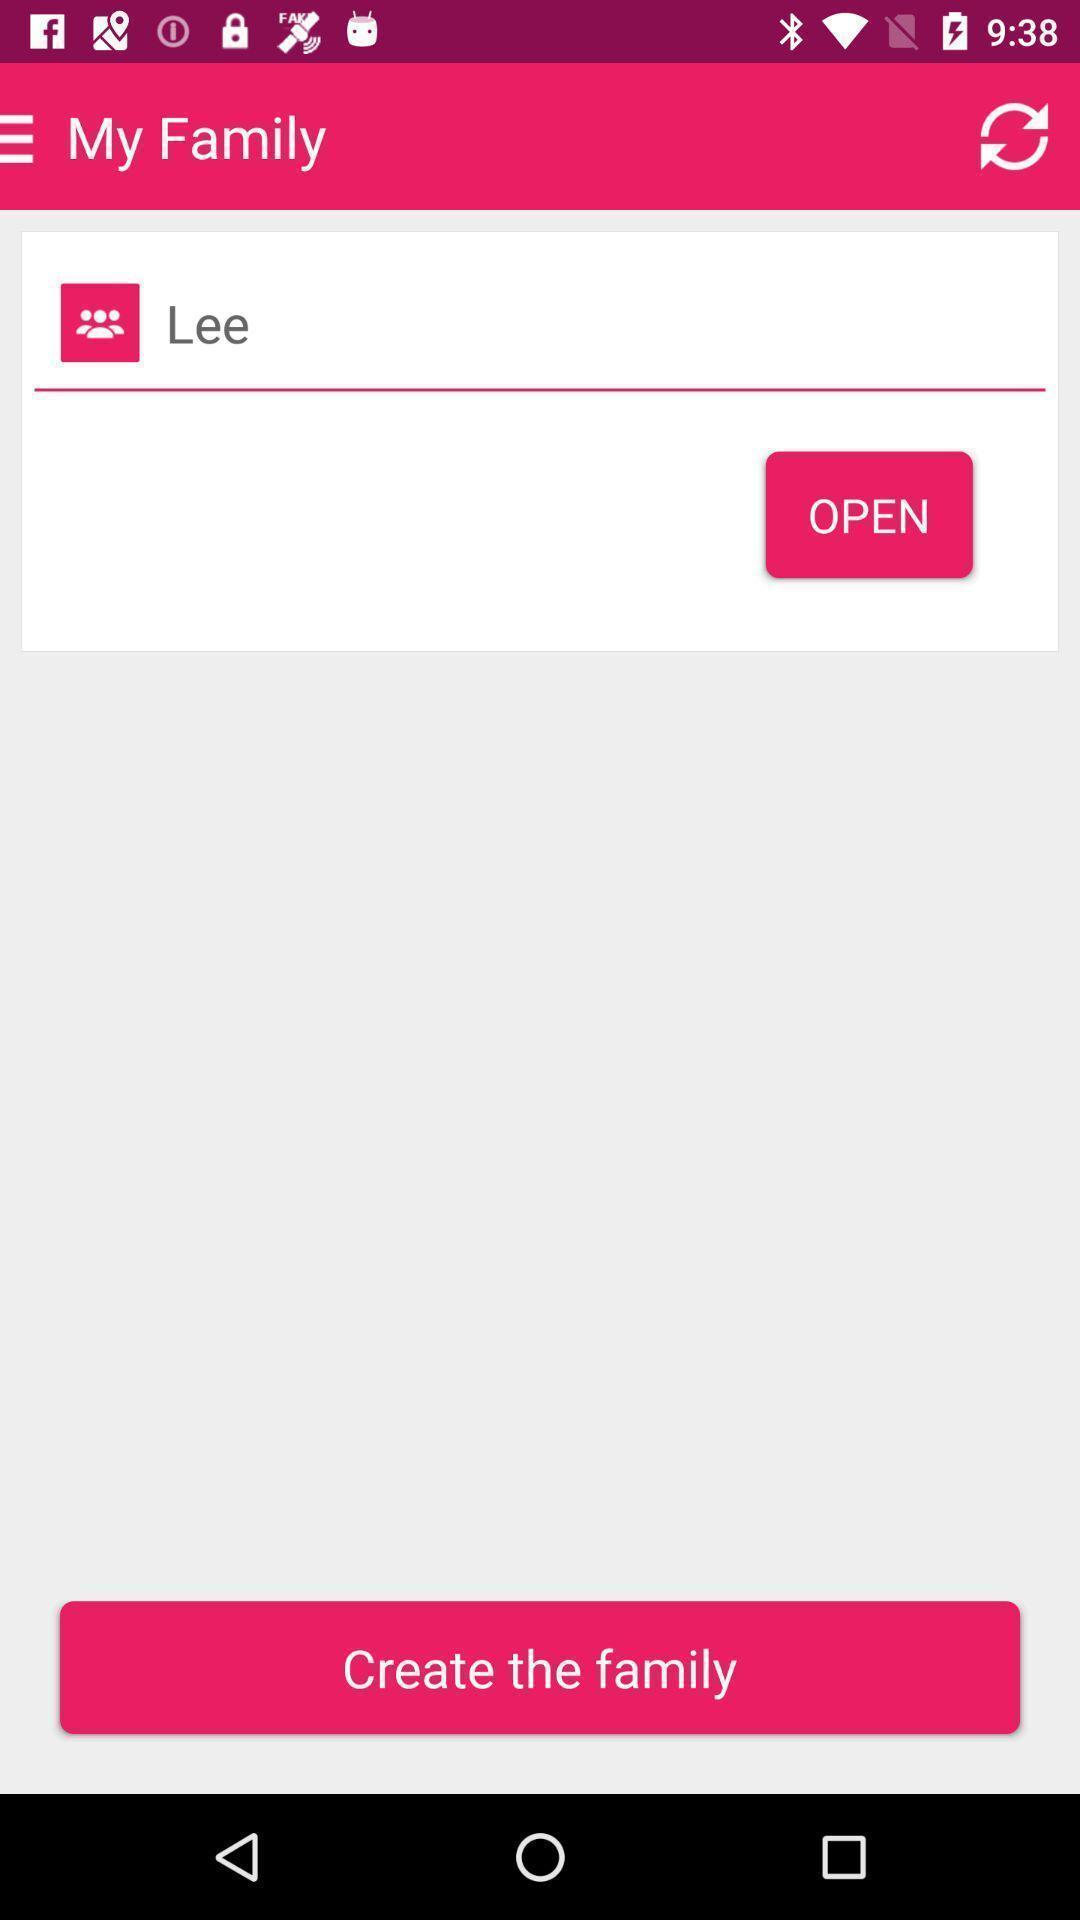Please provide a description for this image. Page to create the family. 